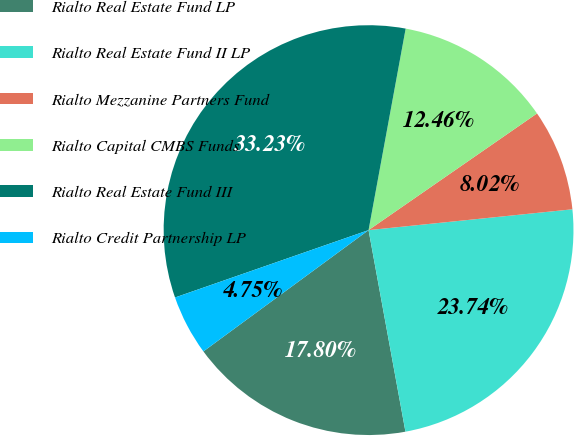Convert chart to OTSL. <chart><loc_0><loc_0><loc_500><loc_500><pie_chart><fcel>Rialto Real Estate Fund LP<fcel>Rialto Real Estate Fund II LP<fcel>Rialto Mezzanine Partners Fund<fcel>Rialto Capital CMBS Funds<fcel>Rialto Real Estate Fund III<fcel>Rialto Credit Partnership LP<nl><fcel>17.8%<fcel>23.74%<fcel>8.02%<fcel>12.46%<fcel>33.23%<fcel>4.75%<nl></chart> 